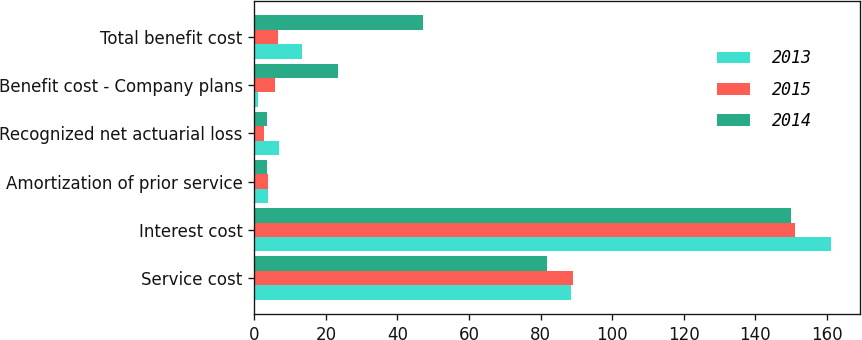Convert chart. <chart><loc_0><loc_0><loc_500><loc_500><stacked_bar_chart><ecel><fcel>Service cost<fcel>Interest cost<fcel>Amortization of prior service<fcel>Recognized net actuarial loss<fcel>Benefit cost - Company plans<fcel>Total benefit cost<nl><fcel>2013<fcel>88.5<fcel>161.3<fcel>3.7<fcel>6.9<fcel>0.9<fcel>13.3<nl><fcel>2015<fcel>89<fcel>151.1<fcel>3.8<fcel>2.7<fcel>5.9<fcel>6.7<nl><fcel>2014<fcel>81.8<fcel>150.1<fcel>3.6<fcel>3.6<fcel>23.5<fcel>47.1<nl></chart> 